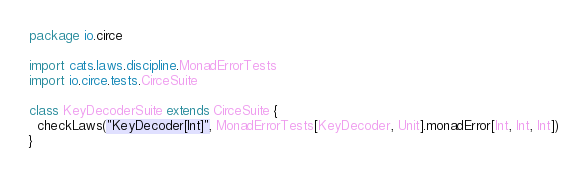Convert code to text. <code><loc_0><loc_0><loc_500><loc_500><_Scala_>package io.circe

import cats.laws.discipline.MonadErrorTests
import io.circe.tests.CirceSuite

class KeyDecoderSuite extends CirceSuite {
  checkLaws("KeyDecoder[Int]", MonadErrorTests[KeyDecoder, Unit].monadError[Int, Int, Int])
}
</code> 